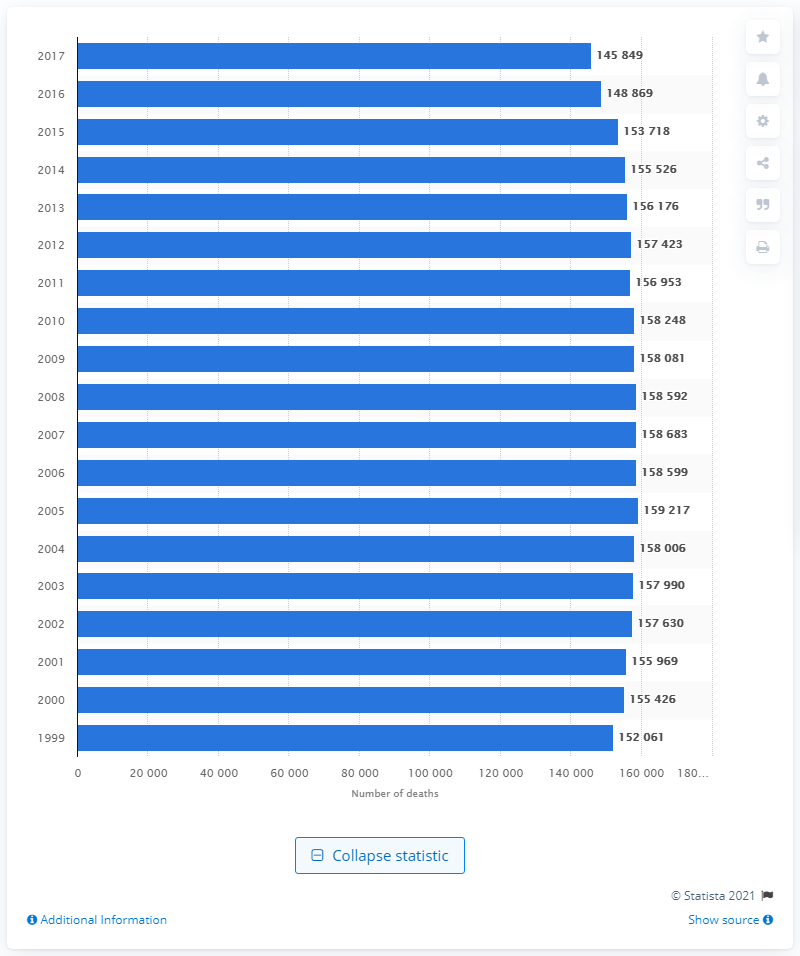Which five-year period in the graph shows the most significant change in death rates due to lung and bronchus cancer? The five-year period between 2000 and 2005 shows the most significant change, where there was a noticeable increase that peaked in 2005. This could prompt further investigation into the factors contributing to this rise. 